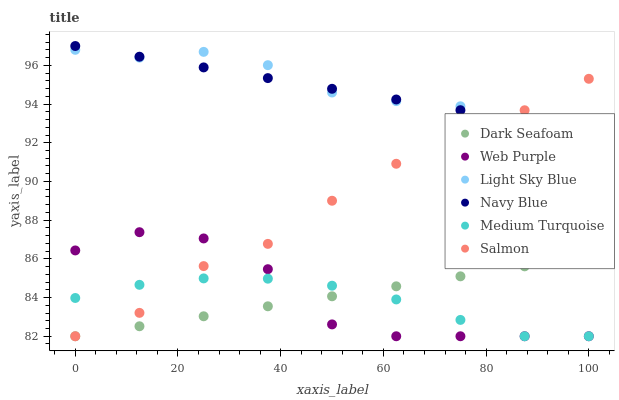Does Medium Turquoise have the minimum area under the curve?
Answer yes or no. Yes. Does Light Sky Blue have the maximum area under the curve?
Answer yes or no. Yes. Does Salmon have the minimum area under the curve?
Answer yes or no. No. Does Salmon have the maximum area under the curve?
Answer yes or no. No. Is Navy Blue the smoothest?
Answer yes or no. Yes. Is Web Purple the roughest?
Answer yes or no. Yes. Is Salmon the smoothest?
Answer yes or no. No. Is Salmon the roughest?
Answer yes or no. No. Does Salmon have the lowest value?
Answer yes or no. Yes. Does Light Sky Blue have the lowest value?
Answer yes or no. No. Does Navy Blue have the highest value?
Answer yes or no. Yes. Does Salmon have the highest value?
Answer yes or no. No. Is Dark Seafoam less than Navy Blue?
Answer yes or no. Yes. Is Navy Blue greater than Web Purple?
Answer yes or no. Yes. Does Dark Seafoam intersect Salmon?
Answer yes or no. Yes. Is Dark Seafoam less than Salmon?
Answer yes or no. No. Is Dark Seafoam greater than Salmon?
Answer yes or no. No. Does Dark Seafoam intersect Navy Blue?
Answer yes or no. No. 